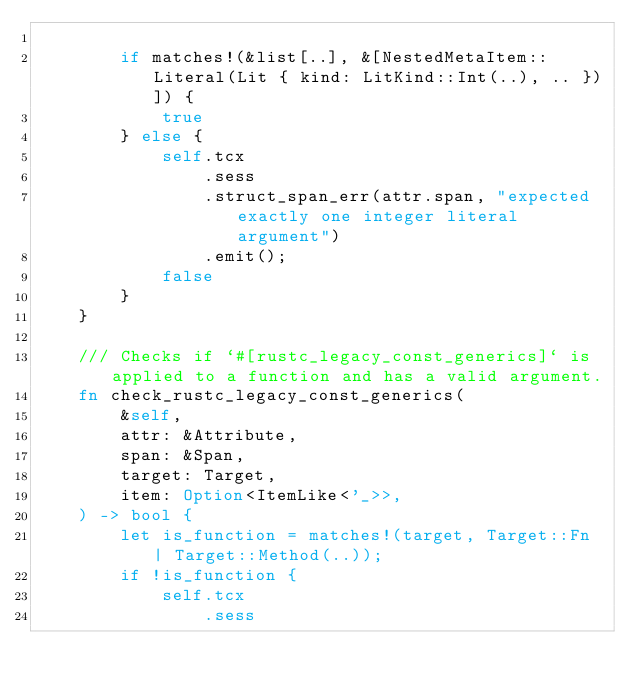Convert code to text. <code><loc_0><loc_0><loc_500><loc_500><_Rust_>
        if matches!(&list[..], &[NestedMetaItem::Literal(Lit { kind: LitKind::Int(..), .. })]) {
            true
        } else {
            self.tcx
                .sess
                .struct_span_err(attr.span, "expected exactly one integer literal argument")
                .emit();
            false
        }
    }

    /// Checks if `#[rustc_legacy_const_generics]` is applied to a function and has a valid argument.
    fn check_rustc_legacy_const_generics(
        &self,
        attr: &Attribute,
        span: &Span,
        target: Target,
        item: Option<ItemLike<'_>>,
    ) -> bool {
        let is_function = matches!(target, Target::Fn | Target::Method(..));
        if !is_function {
            self.tcx
                .sess</code> 